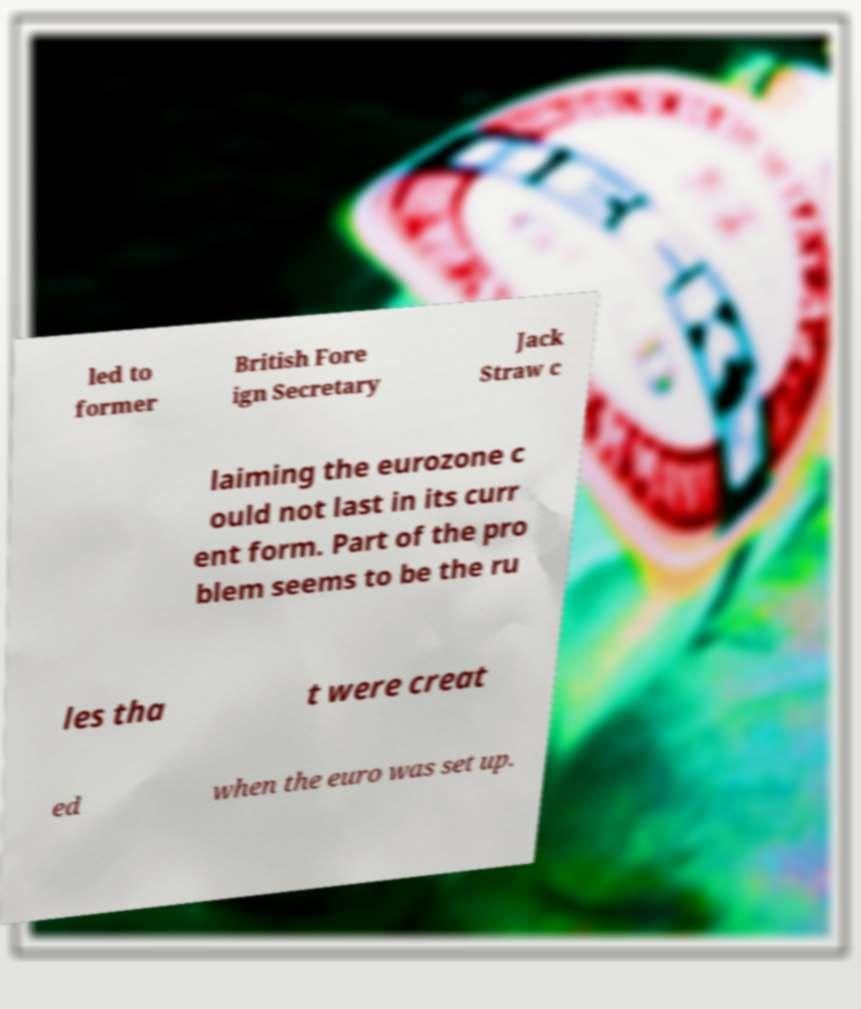There's text embedded in this image that I need extracted. Can you transcribe it verbatim? led to former British Fore ign Secretary Jack Straw c laiming the eurozone c ould not last in its curr ent form. Part of the pro blem seems to be the ru les tha t were creat ed when the euro was set up. 